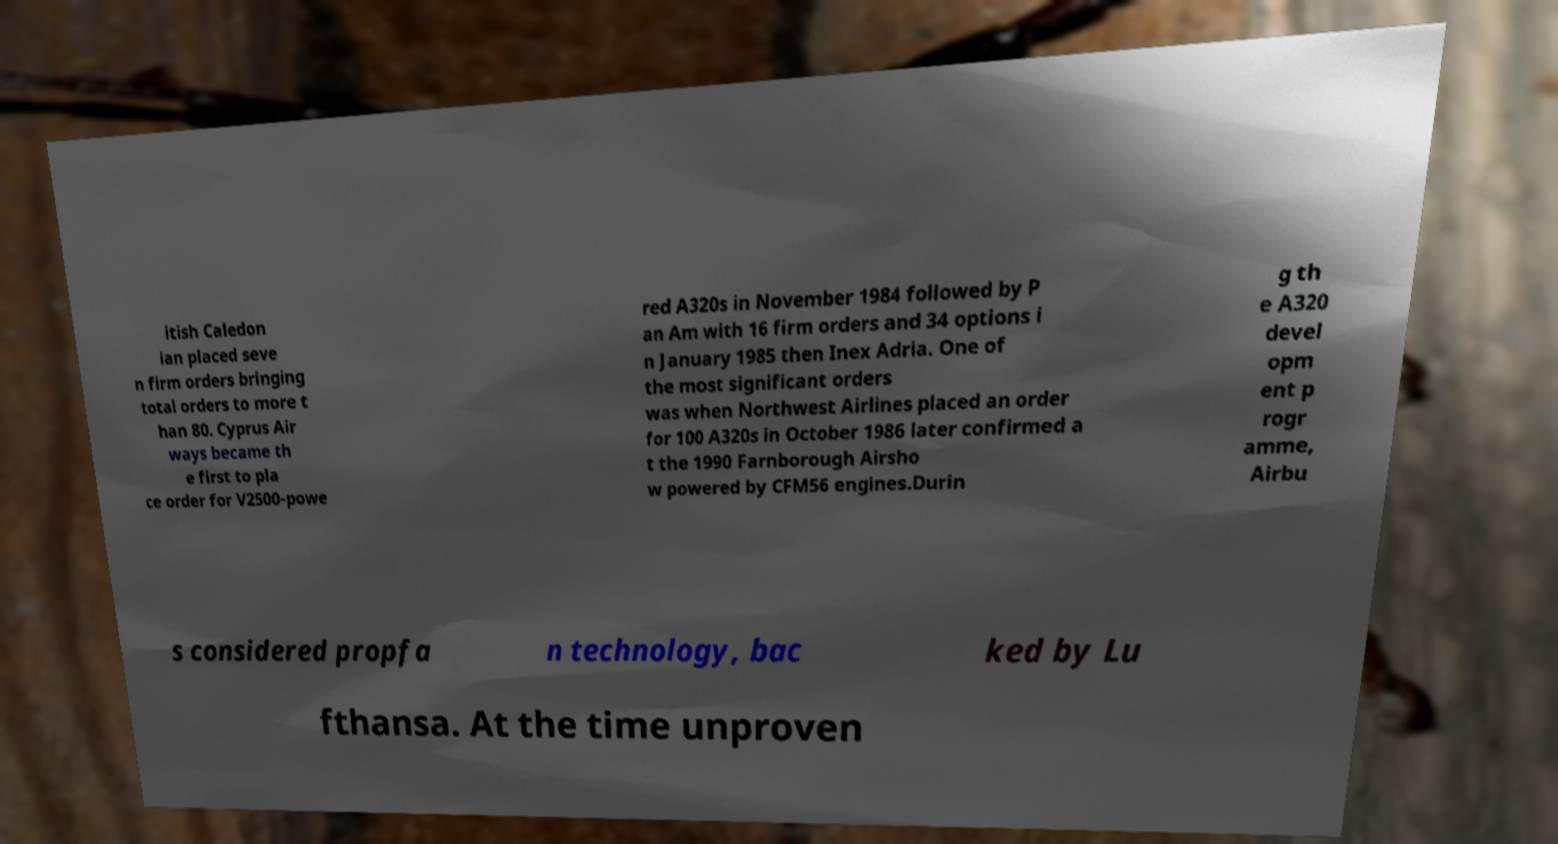Can you accurately transcribe the text from the provided image for me? itish Caledon ian placed seve n firm orders bringing total orders to more t han 80. Cyprus Air ways became th e first to pla ce order for V2500-powe red A320s in November 1984 followed by P an Am with 16 firm orders and 34 options i n January 1985 then Inex Adria. One of the most significant orders was when Northwest Airlines placed an order for 100 A320s in October 1986 later confirmed a t the 1990 Farnborough Airsho w powered by CFM56 engines.Durin g th e A320 devel opm ent p rogr amme, Airbu s considered propfa n technology, bac ked by Lu fthansa. At the time unproven 